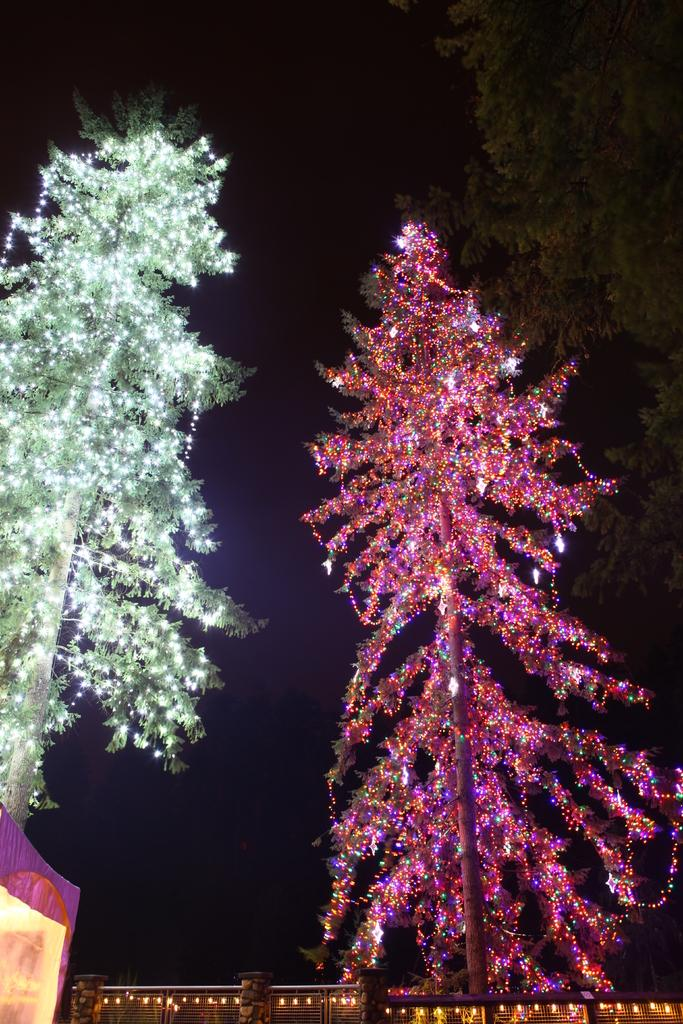What is the main feature of the image? The main feature of the image is two trees decorated with lights. Are there any other objects or structures in the image that are also decorated with lights? Yes, the fence under the trees is also decorated with lights. Are there any other trees in the image? Yes, there is another normal tree beside the decorated trees. How many dogs can be seen playing with ants in the image? There are no dogs or ants present in the image; it only features trees and lights. 